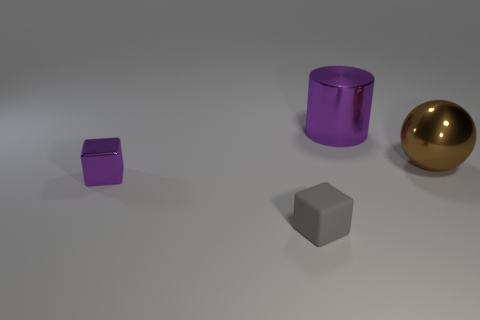Add 3 tiny gray things. How many objects exist? 7 Subtract all cylinders. How many objects are left? 3 Subtract all brown metallic balls. Subtract all gray cubes. How many objects are left? 2 Add 2 large metal spheres. How many large metal spheres are left? 3 Add 4 small gray objects. How many small gray objects exist? 5 Subtract 0 green cylinders. How many objects are left? 4 